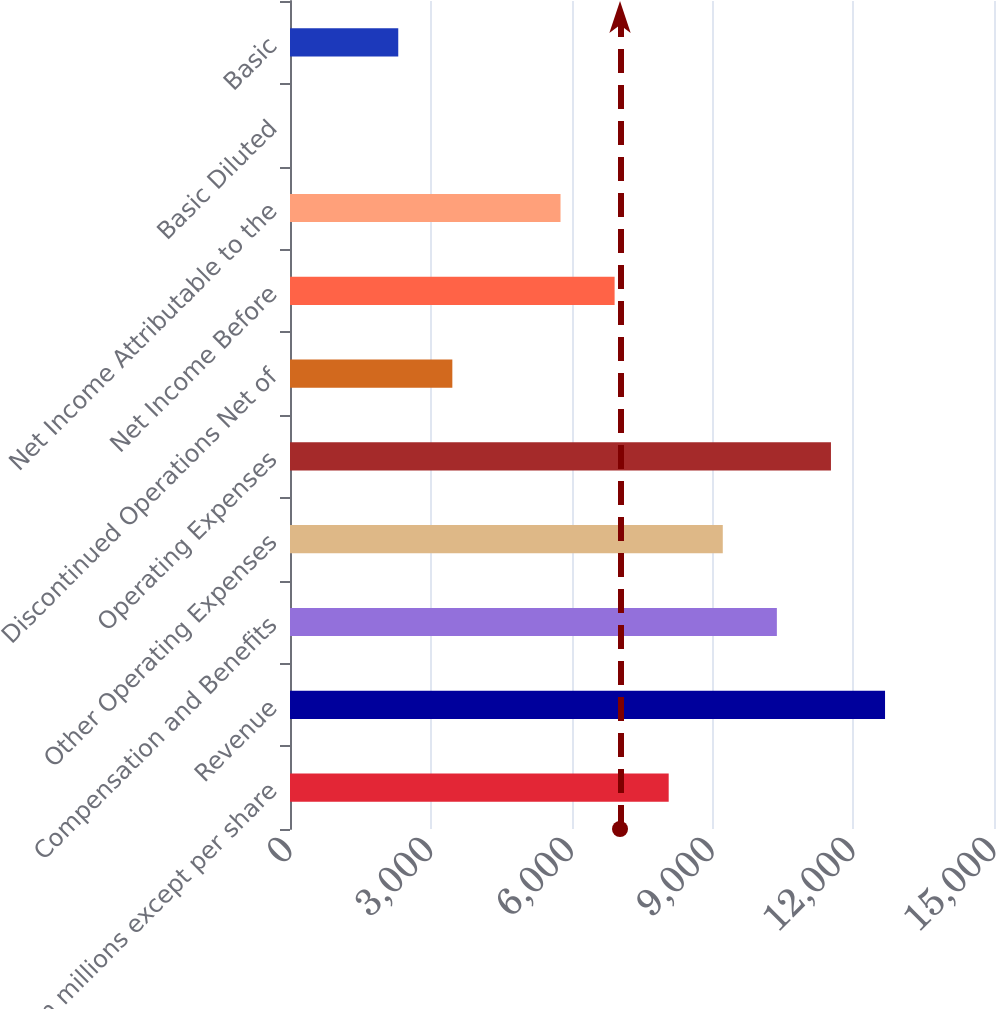<chart> <loc_0><loc_0><loc_500><loc_500><bar_chart><fcel>(In millions except per share<fcel>Revenue<fcel>Compensation and Benefits<fcel>Other Operating Expenses<fcel>Operating Expenses<fcel>Discontinued Operations Net of<fcel>Net Income Before<fcel>Net Income Attributable to the<fcel>Basic Diluted<fcel>Basic<nl><fcel>8068.74<fcel>12678.5<fcel>10373.6<fcel>9221.17<fcel>11526<fcel>3459.02<fcel>6916.31<fcel>5763.88<fcel>1.73<fcel>2306.59<nl></chart> 